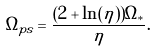<formula> <loc_0><loc_0><loc_500><loc_500>\Omega _ { p s } = \frac { ( 2 + \ln ( \eta ) ) \Omega _ { * } } { \eta } .</formula> 